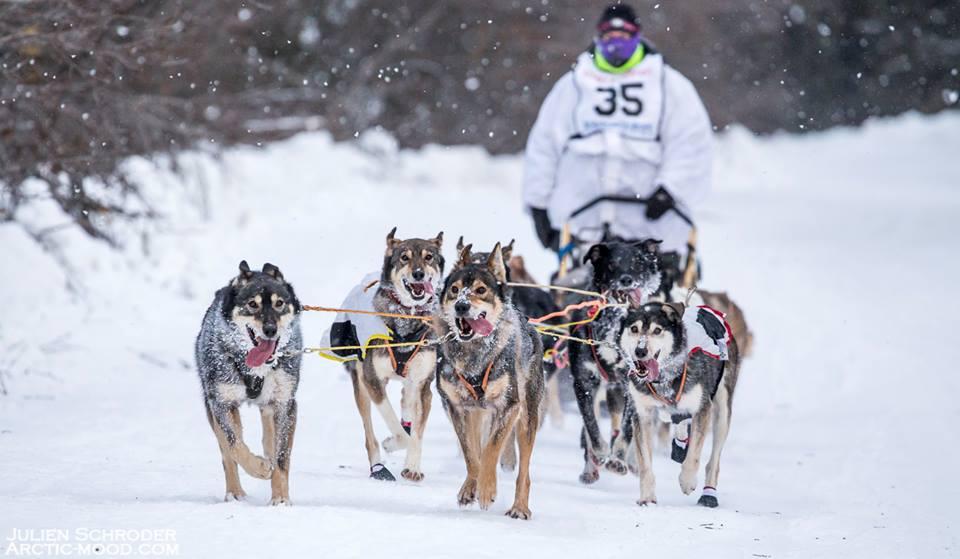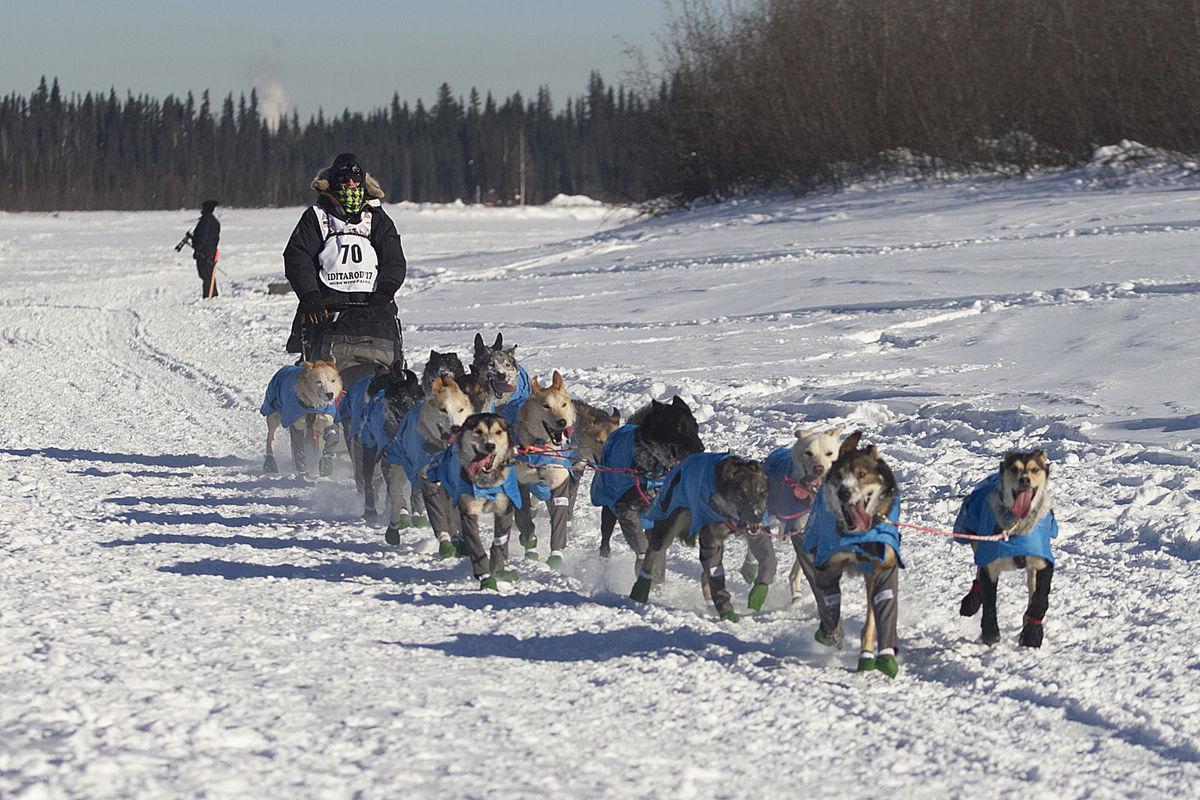The first image is the image on the left, the second image is the image on the right. Considering the images on both sides, is "The person driving the sled in the image on the right is wearing a white numbered vest." valid? Answer yes or no. Yes. The first image is the image on the left, the second image is the image on the right. Assess this claim about the two images: "At least one man is riding a sled wearing a white vest that is numbered.". Correct or not? Answer yes or no. Yes. 